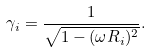Convert formula to latex. <formula><loc_0><loc_0><loc_500><loc_500>\gamma _ { i } = \frac { 1 } { \sqrt { 1 - ( \omega R _ { i } ) ^ { 2 } } } .</formula> 